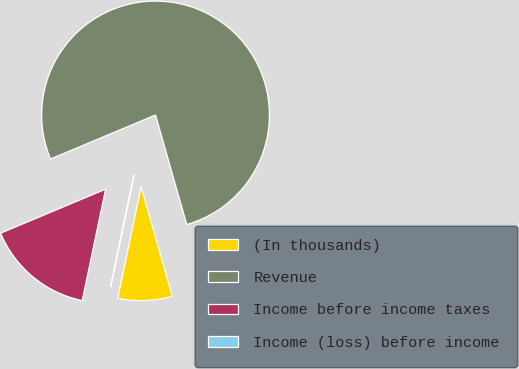Convert chart. <chart><loc_0><loc_0><loc_500><loc_500><pie_chart><fcel>(In thousands)<fcel>Revenue<fcel>Income before income taxes<fcel>Income (loss) before income<nl><fcel>7.7%<fcel>76.9%<fcel>15.39%<fcel>0.01%<nl></chart> 